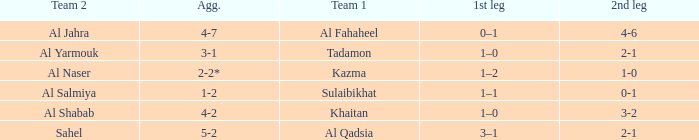What is the name of Team 2 with a Team 1 of Al Qadsia? Sahel. 